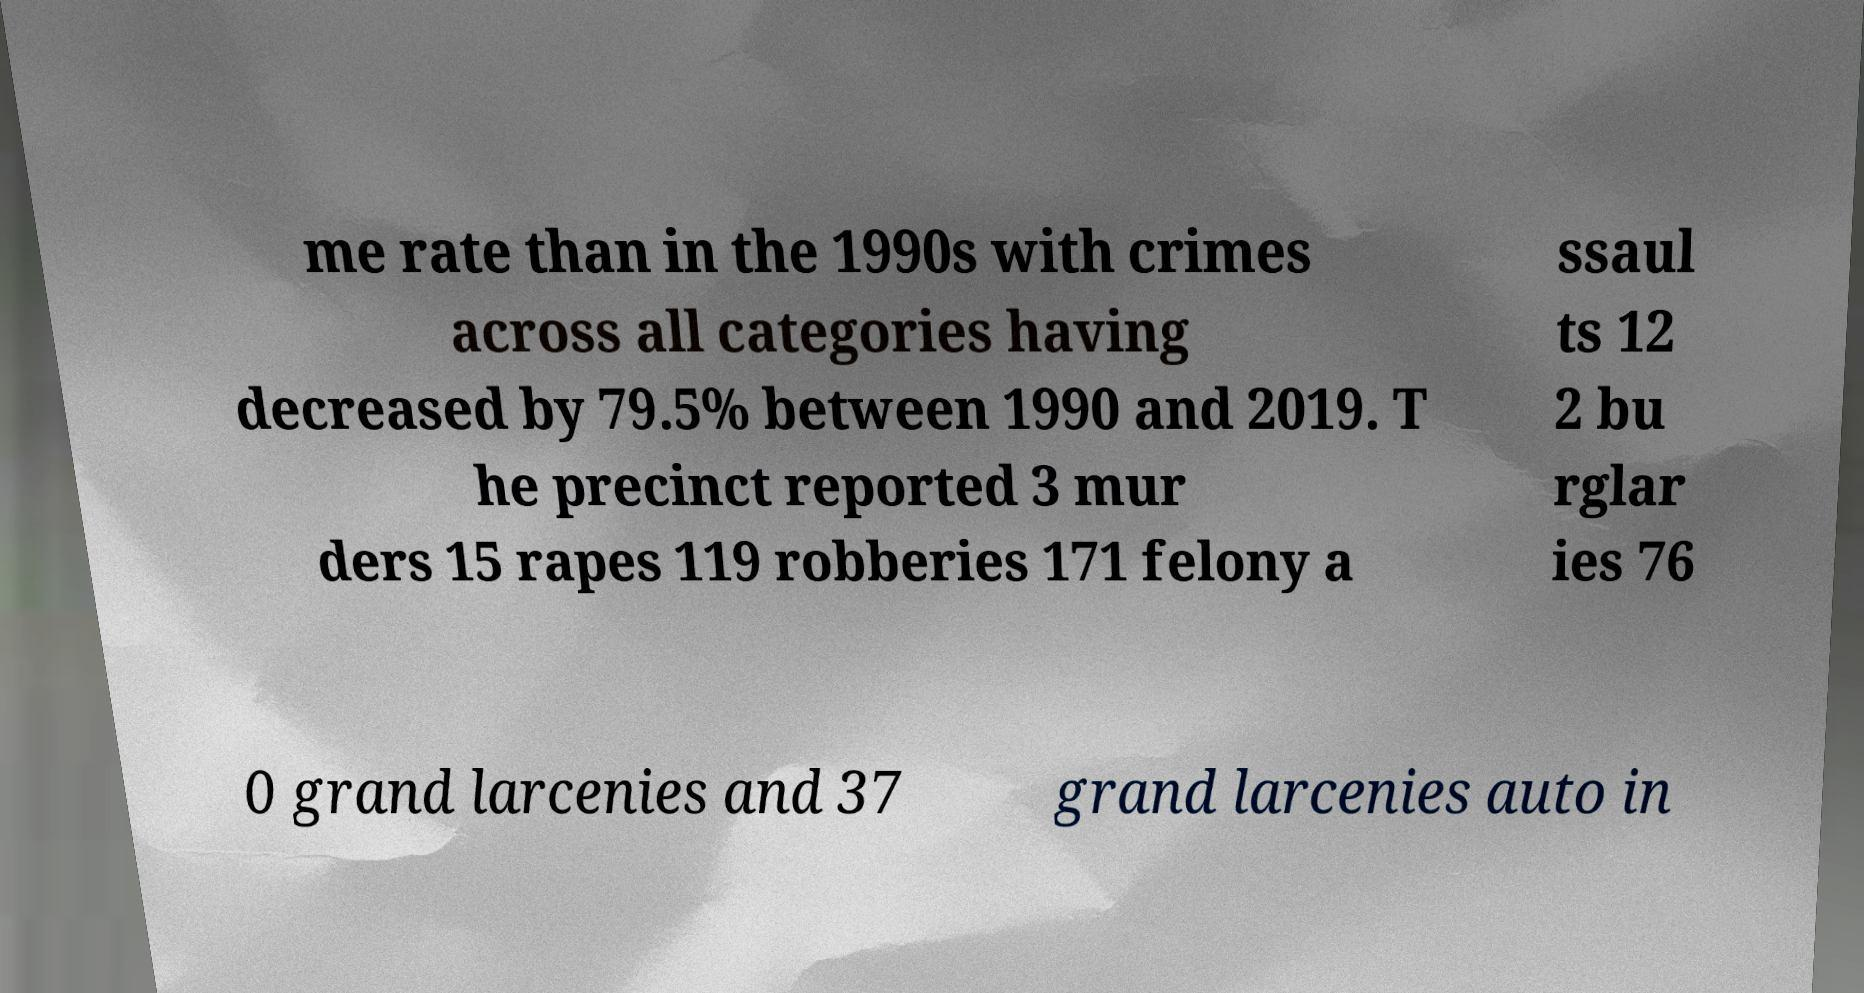For documentation purposes, I need the text within this image transcribed. Could you provide that? me rate than in the 1990s with crimes across all categories having decreased by 79.5% between 1990 and 2019. T he precinct reported 3 mur ders 15 rapes 119 robberies 171 felony a ssaul ts 12 2 bu rglar ies 76 0 grand larcenies and 37 grand larcenies auto in 